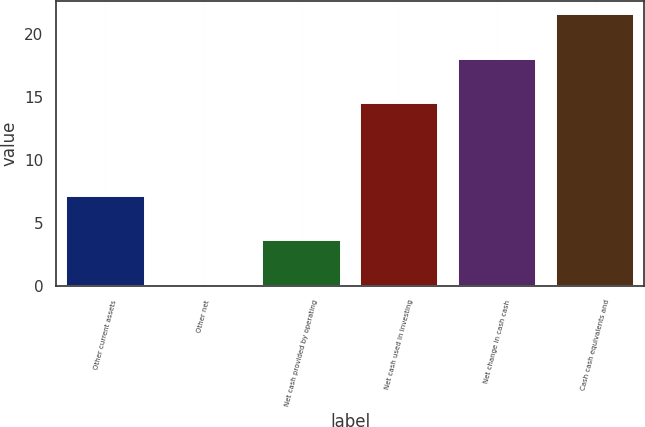<chart> <loc_0><loc_0><loc_500><loc_500><bar_chart><fcel>Other current assets<fcel>Other net<fcel>Net cash provided by operating<fcel>Net cash used in investing<fcel>Net change in cash cash<fcel>Cash cash equivalents and<nl><fcel>7.12<fcel>0.1<fcel>3.61<fcel>14.5<fcel>18.01<fcel>21.52<nl></chart> 